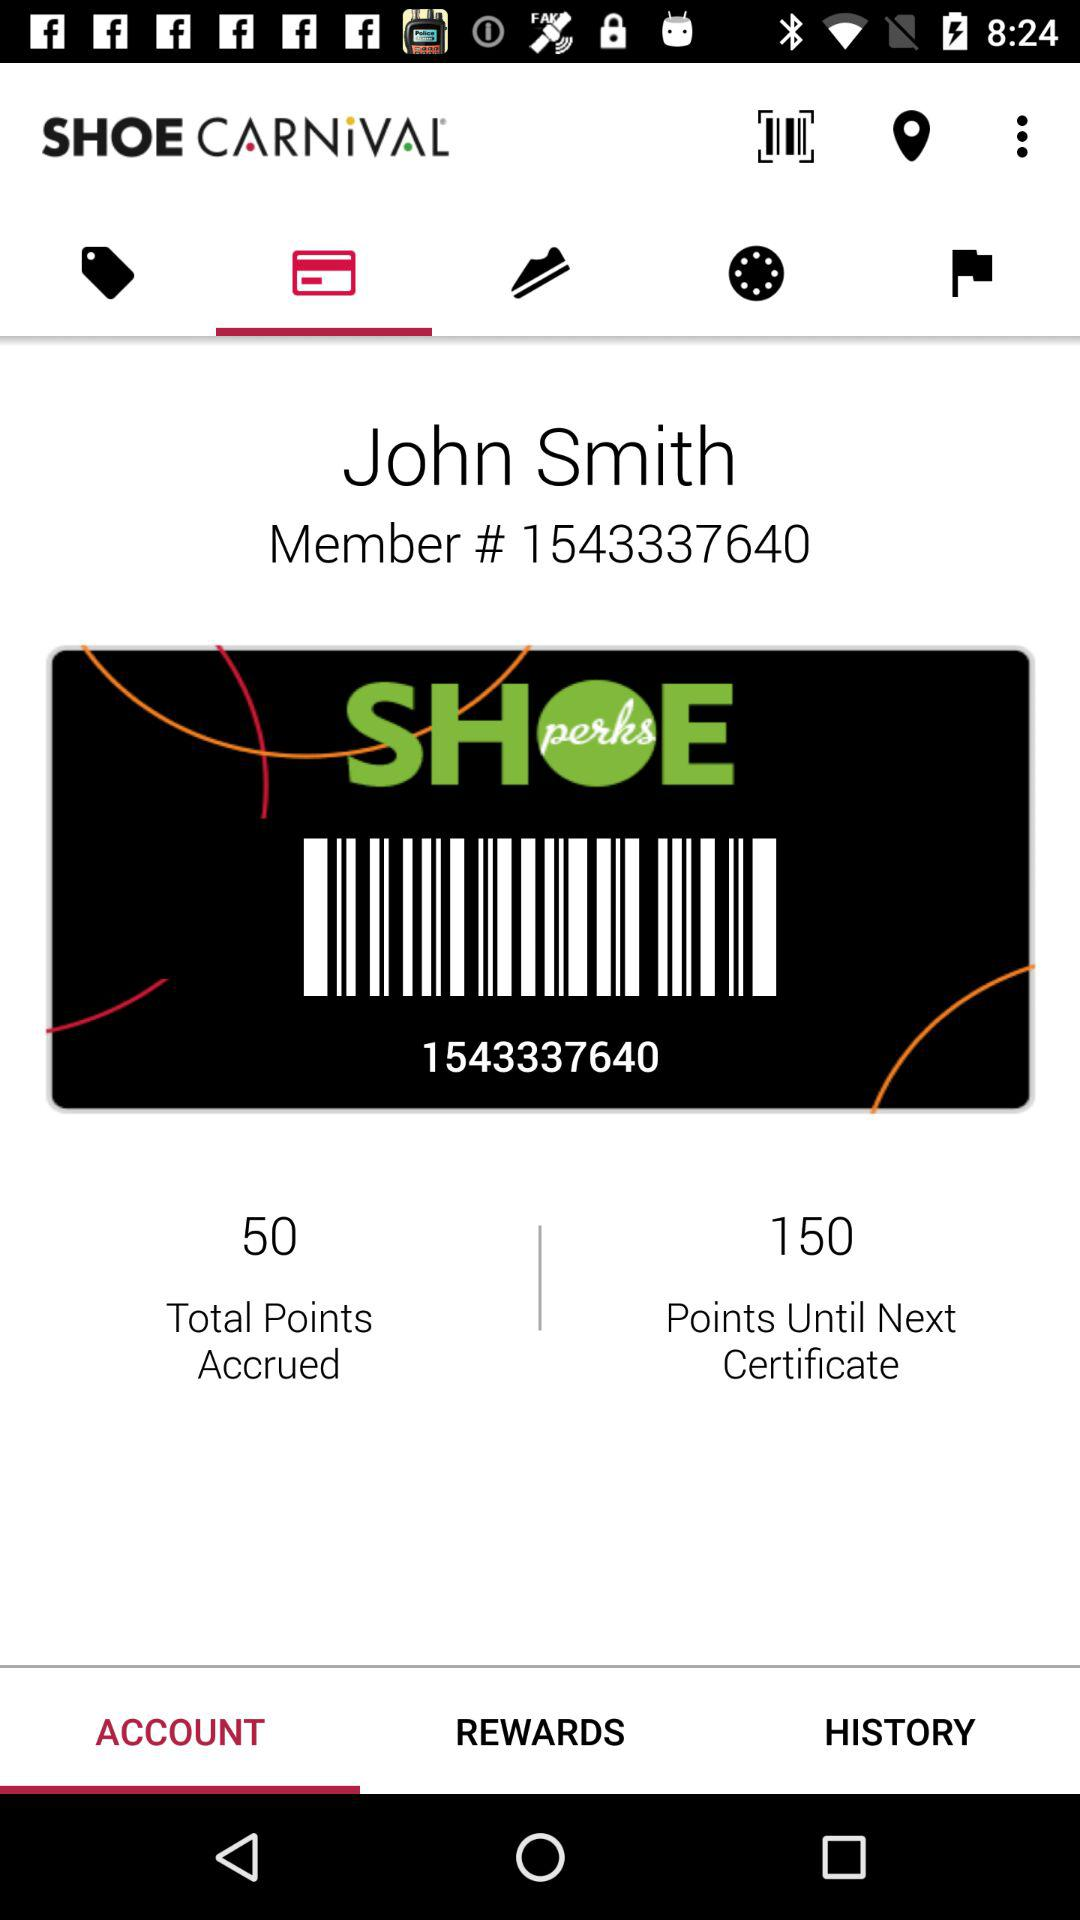What is the application name? The application name is "SHOW CARNiVAL". 